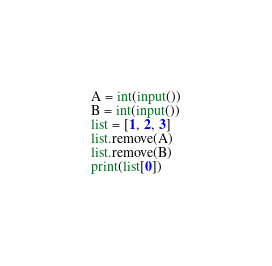<code> <loc_0><loc_0><loc_500><loc_500><_Python_>A = int(input())
B = int(input())
list = [1, 2, 3]
list.remove(A)
list.remove(B)
print(list[0])</code> 